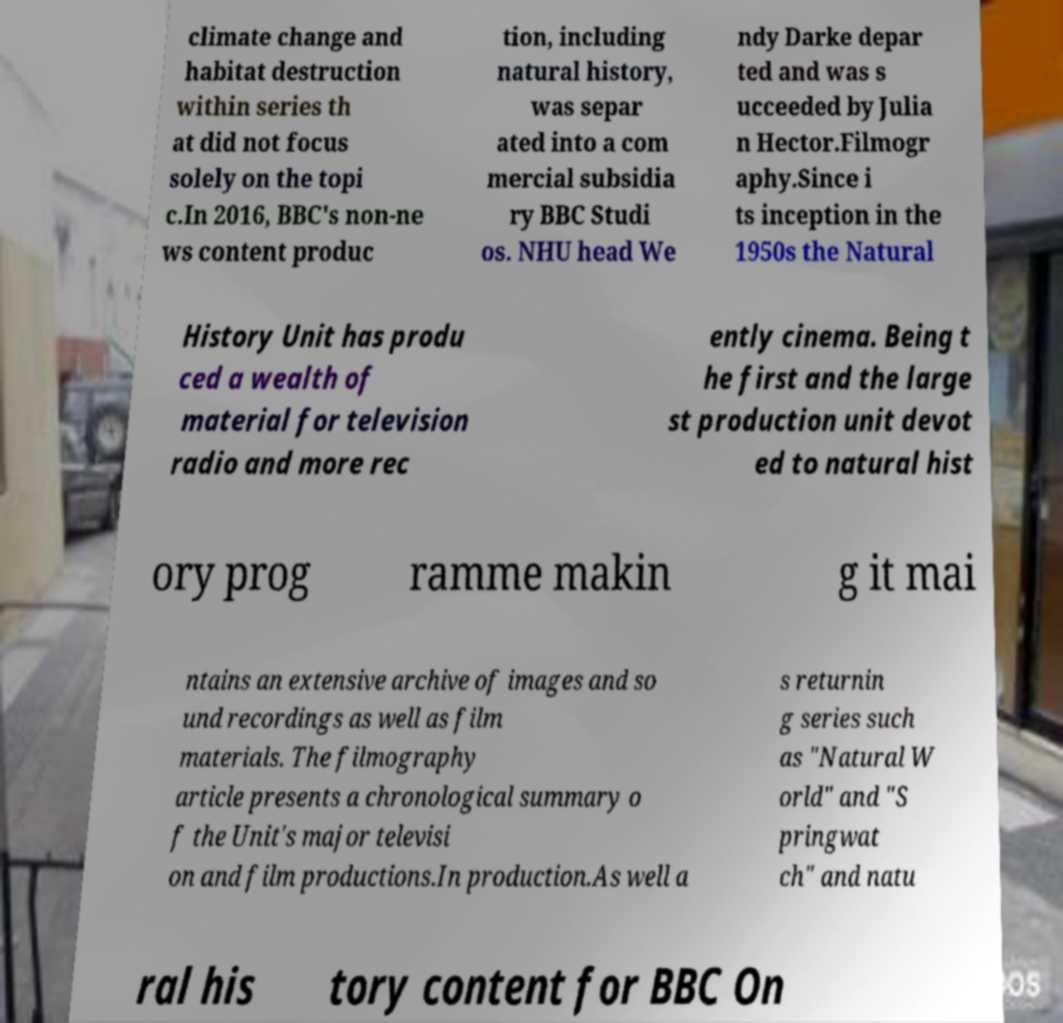Could you assist in decoding the text presented in this image and type it out clearly? climate change and habitat destruction within series th at did not focus solely on the topi c.In 2016, BBC's non-ne ws content produc tion, including natural history, was separ ated into a com mercial subsidia ry BBC Studi os. NHU head We ndy Darke depar ted and was s ucceeded by Julia n Hector.Filmogr aphy.Since i ts inception in the 1950s the Natural History Unit has produ ced a wealth of material for television radio and more rec ently cinema. Being t he first and the large st production unit devot ed to natural hist ory prog ramme makin g it mai ntains an extensive archive of images and so und recordings as well as film materials. The filmography article presents a chronological summary o f the Unit's major televisi on and film productions.In production.As well a s returnin g series such as "Natural W orld" and "S pringwat ch" and natu ral his tory content for BBC On 